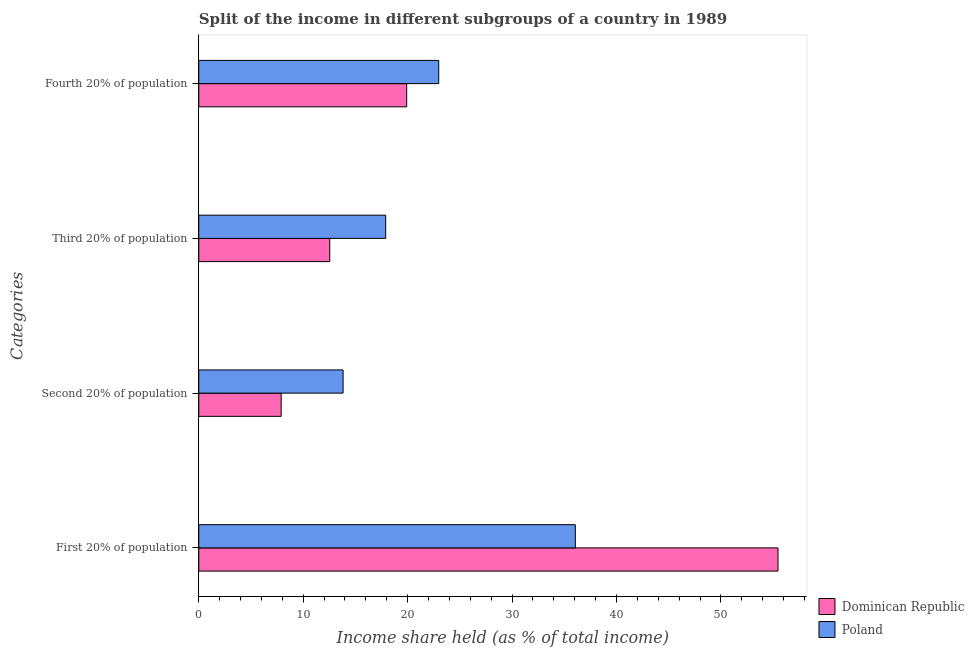How many different coloured bars are there?
Your answer should be very brief. 2. Are the number of bars per tick equal to the number of legend labels?
Offer a terse response. Yes. Are the number of bars on each tick of the Y-axis equal?
Your answer should be compact. Yes. How many bars are there on the 3rd tick from the top?
Your response must be concise. 2. How many bars are there on the 2nd tick from the bottom?
Provide a succinct answer. 2. What is the label of the 3rd group of bars from the top?
Your answer should be compact. Second 20% of population. What is the share of the income held by fourth 20% of the population in Dominican Republic?
Provide a succinct answer. 19.91. Across all countries, what is the minimum share of the income held by fourth 20% of the population?
Make the answer very short. 19.91. In which country was the share of the income held by third 20% of the population maximum?
Keep it short and to the point. Poland. In which country was the share of the income held by second 20% of the population minimum?
Keep it short and to the point. Dominican Republic. What is the total share of the income held by fourth 20% of the population in the graph?
Your answer should be very brief. 42.89. What is the difference between the share of the income held by third 20% of the population in Poland and that in Dominican Republic?
Make the answer very short. 5.36. What is the difference between the share of the income held by third 20% of the population in Dominican Republic and the share of the income held by second 20% of the population in Poland?
Provide a succinct answer. -1.28. What is the average share of the income held by fourth 20% of the population per country?
Your response must be concise. 21.45. What is the difference between the share of the income held by second 20% of the population and share of the income held by fourth 20% of the population in Dominican Republic?
Make the answer very short. -12.02. What is the ratio of the share of the income held by second 20% of the population in Dominican Republic to that in Poland?
Provide a succinct answer. 0.57. Is the difference between the share of the income held by fourth 20% of the population in Dominican Republic and Poland greater than the difference between the share of the income held by third 20% of the population in Dominican Republic and Poland?
Make the answer very short. Yes. What is the difference between the highest and the second highest share of the income held by first 20% of the population?
Offer a very short reply. 19.41. What is the difference between the highest and the lowest share of the income held by fourth 20% of the population?
Provide a short and direct response. 3.07. Is the sum of the share of the income held by fourth 20% of the population in Poland and Dominican Republic greater than the maximum share of the income held by first 20% of the population across all countries?
Offer a very short reply. No. Is it the case that in every country, the sum of the share of the income held by first 20% of the population and share of the income held by second 20% of the population is greater than the sum of share of the income held by fourth 20% of the population and share of the income held by third 20% of the population?
Provide a succinct answer. Yes. What does the 1st bar from the top in Third 20% of population represents?
Your response must be concise. Poland. What does the 1st bar from the bottom in First 20% of population represents?
Provide a succinct answer. Dominican Republic. Does the graph contain any zero values?
Ensure brevity in your answer.  No. Where does the legend appear in the graph?
Your answer should be very brief. Bottom right. What is the title of the graph?
Your response must be concise. Split of the income in different subgroups of a country in 1989. Does "Oman" appear as one of the legend labels in the graph?
Offer a terse response. No. What is the label or title of the X-axis?
Ensure brevity in your answer.  Income share held (as % of total income). What is the label or title of the Y-axis?
Provide a succinct answer. Categories. What is the Income share held (as % of total income) of Dominican Republic in First 20% of population?
Your response must be concise. 55.47. What is the Income share held (as % of total income) in Poland in First 20% of population?
Provide a succinct answer. 36.06. What is the Income share held (as % of total income) in Dominican Republic in Second 20% of population?
Your answer should be very brief. 7.89. What is the Income share held (as % of total income) of Poland in Second 20% of population?
Give a very brief answer. 13.82. What is the Income share held (as % of total income) in Dominican Republic in Third 20% of population?
Make the answer very short. 12.54. What is the Income share held (as % of total income) of Dominican Republic in Fourth 20% of population?
Your response must be concise. 19.91. What is the Income share held (as % of total income) of Poland in Fourth 20% of population?
Give a very brief answer. 22.98. Across all Categories, what is the maximum Income share held (as % of total income) of Dominican Republic?
Offer a very short reply. 55.47. Across all Categories, what is the maximum Income share held (as % of total income) in Poland?
Offer a terse response. 36.06. Across all Categories, what is the minimum Income share held (as % of total income) of Dominican Republic?
Provide a succinct answer. 7.89. Across all Categories, what is the minimum Income share held (as % of total income) of Poland?
Your response must be concise. 13.82. What is the total Income share held (as % of total income) in Dominican Republic in the graph?
Provide a short and direct response. 95.81. What is the total Income share held (as % of total income) of Poland in the graph?
Offer a very short reply. 90.76. What is the difference between the Income share held (as % of total income) of Dominican Republic in First 20% of population and that in Second 20% of population?
Provide a succinct answer. 47.58. What is the difference between the Income share held (as % of total income) in Poland in First 20% of population and that in Second 20% of population?
Make the answer very short. 22.24. What is the difference between the Income share held (as % of total income) of Dominican Republic in First 20% of population and that in Third 20% of population?
Offer a terse response. 42.93. What is the difference between the Income share held (as % of total income) of Poland in First 20% of population and that in Third 20% of population?
Your answer should be very brief. 18.16. What is the difference between the Income share held (as % of total income) in Dominican Republic in First 20% of population and that in Fourth 20% of population?
Your answer should be very brief. 35.56. What is the difference between the Income share held (as % of total income) in Poland in First 20% of population and that in Fourth 20% of population?
Make the answer very short. 13.08. What is the difference between the Income share held (as % of total income) in Dominican Republic in Second 20% of population and that in Third 20% of population?
Offer a terse response. -4.65. What is the difference between the Income share held (as % of total income) in Poland in Second 20% of population and that in Third 20% of population?
Offer a terse response. -4.08. What is the difference between the Income share held (as % of total income) of Dominican Republic in Second 20% of population and that in Fourth 20% of population?
Offer a terse response. -12.02. What is the difference between the Income share held (as % of total income) in Poland in Second 20% of population and that in Fourth 20% of population?
Offer a terse response. -9.16. What is the difference between the Income share held (as % of total income) in Dominican Republic in Third 20% of population and that in Fourth 20% of population?
Your response must be concise. -7.37. What is the difference between the Income share held (as % of total income) of Poland in Third 20% of population and that in Fourth 20% of population?
Your answer should be compact. -5.08. What is the difference between the Income share held (as % of total income) of Dominican Republic in First 20% of population and the Income share held (as % of total income) of Poland in Second 20% of population?
Give a very brief answer. 41.65. What is the difference between the Income share held (as % of total income) of Dominican Republic in First 20% of population and the Income share held (as % of total income) of Poland in Third 20% of population?
Your answer should be compact. 37.57. What is the difference between the Income share held (as % of total income) of Dominican Republic in First 20% of population and the Income share held (as % of total income) of Poland in Fourth 20% of population?
Give a very brief answer. 32.49. What is the difference between the Income share held (as % of total income) of Dominican Republic in Second 20% of population and the Income share held (as % of total income) of Poland in Third 20% of population?
Provide a succinct answer. -10.01. What is the difference between the Income share held (as % of total income) in Dominican Republic in Second 20% of population and the Income share held (as % of total income) in Poland in Fourth 20% of population?
Offer a terse response. -15.09. What is the difference between the Income share held (as % of total income) in Dominican Republic in Third 20% of population and the Income share held (as % of total income) in Poland in Fourth 20% of population?
Offer a terse response. -10.44. What is the average Income share held (as % of total income) of Dominican Republic per Categories?
Give a very brief answer. 23.95. What is the average Income share held (as % of total income) of Poland per Categories?
Your response must be concise. 22.69. What is the difference between the Income share held (as % of total income) in Dominican Republic and Income share held (as % of total income) in Poland in First 20% of population?
Your response must be concise. 19.41. What is the difference between the Income share held (as % of total income) in Dominican Republic and Income share held (as % of total income) in Poland in Second 20% of population?
Offer a very short reply. -5.93. What is the difference between the Income share held (as % of total income) in Dominican Republic and Income share held (as % of total income) in Poland in Third 20% of population?
Keep it short and to the point. -5.36. What is the difference between the Income share held (as % of total income) of Dominican Republic and Income share held (as % of total income) of Poland in Fourth 20% of population?
Provide a succinct answer. -3.07. What is the ratio of the Income share held (as % of total income) in Dominican Republic in First 20% of population to that in Second 20% of population?
Provide a short and direct response. 7.03. What is the ratio of the Income share held (as % of total income) in Poland in First 20% of population to that in Second 20% of population?
Make the answer very short. 2.61. What is the ratio of the Income share held (as % of total income) in Dominican Republic in First 20% of population to that in Third 20% of population?
Your response must be concise. 4.42. What is the ratio of the Income share held (as % of total income) in Poland in First 20% of population to that in Third 20% of population?
Provide a short and direct response. 2.01. What is the ratio of the Income share held (as % of total income) in Dominican Republic in First 20% of population to that in Fourth 20% of population?
Keep it short and to the point. 2.79. What is the ratio of the Income share held (as % of total income) of Poland in First 20% of population to that in Fourth 20% of population?
Make the answer very short. 1.57. What is the ratio of the Income share held (as % of total income) of Dominican Republic in Second 20% of population to that in Third 20% of population?
Make the answer very short. 0.63. What is the ratio of the Income share held (as % of total income) of Poland in Second 20% of population to that in Third 20% of population?
Offer a very short reply. 0.77. What is the ratio of the Income share held (as % of total income) of Dominican Republic in Second 20% of population to that in Fourth 20% of population?
Your answer should be compact. 0.4. What is the ratio of the Income share held (as % of total income) of Poland in Second 20% of population to that in Fourth 20% of population?
Offer a terse response. 0.6. What is the ratio of the Income share held (as % of total income) in Dominican Republic in Third 20% of population to that in Fourth 20% of population?
Keep it short and to the point. 0.63. What is the ratio of the Income share held (as % of total income) in Poland in Third 20% of population to that in Fourth 20% of population?
Your response must be concise. 0.78. What is the difference between the highest and the second highest Income share held (as % of total income) of Dominican Republic?
Your answer should be compact. 35.56. What is the difference between the highest and the second highest Income share held (as % of total income) of Poland?
Provide a short and direct response. 13.08. What is the difference between the highest and the lowest Income share held (as % of total income) in Dominican Republic?
Provide a succinct answer. 47.58. What is the difference between the highest and the lowest Income share held (as % of total income) of Poland?
Your answer should be very brief. 22.24. 